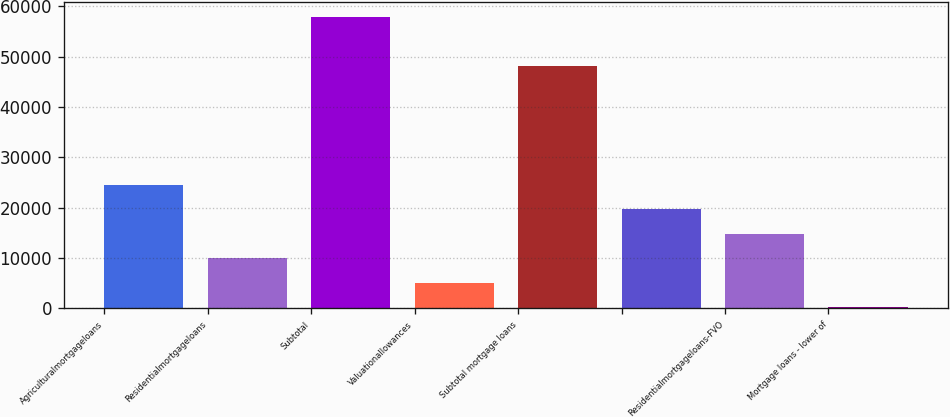Convert chart to OTSL. <chart><loc_0><loc_0><loc_500><loc_500><bar_chart><fcel>Agriculturalmortgageloans<fcel>Residentialmortgageloans<fcel>Subtotal<fcel>Valuationallowances<fcel>Subtotal mortgage loans<fcel>Unnamed: 5<fcel>Residentialmortgageloans-FVO<fcel>Mortgage loans - lower of<nl><fcel>24580<fcel>9986.8<fcel>57909.8<fcel>5122.4<fcel>48181<fcel>19715.6<fcel>14851.2<fcel>258<nl></chart> 